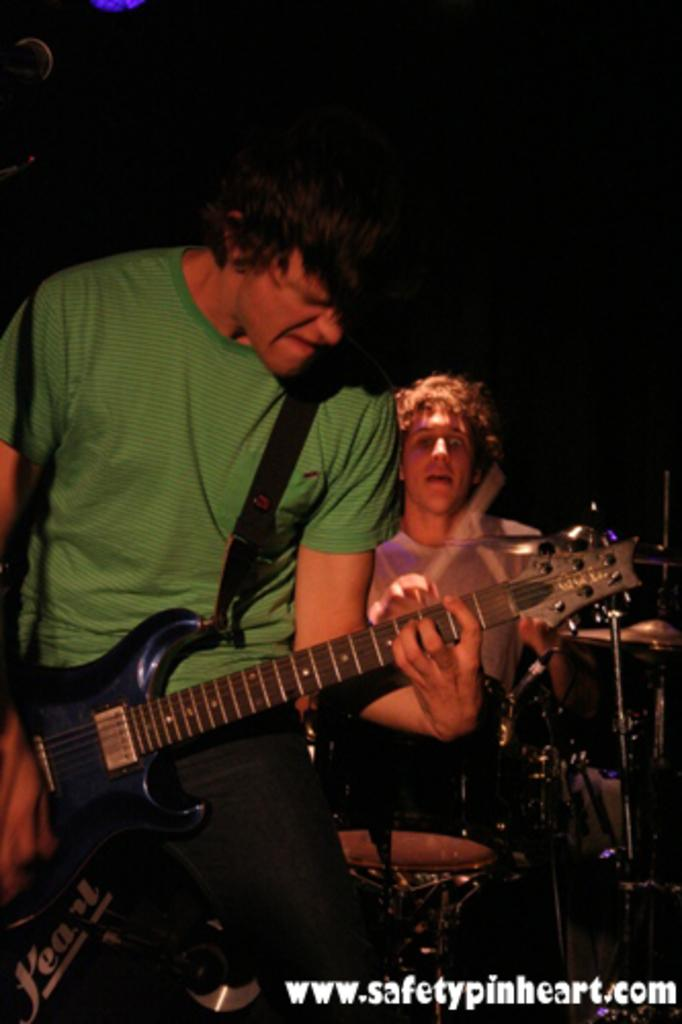How many people are in the image? There are two men in the image. What are the men doing in the image? The man on the left is playing a guitar, and the man on the right is playing drums. What objects are in front of the men? There are microphones in front of the men. How many houses can be seen in the image? There are no houses visible in the image. What type of snail is crawling on the shirt of the man on the left? There is no snail present in the image, and therefore no such activity can be observed. 